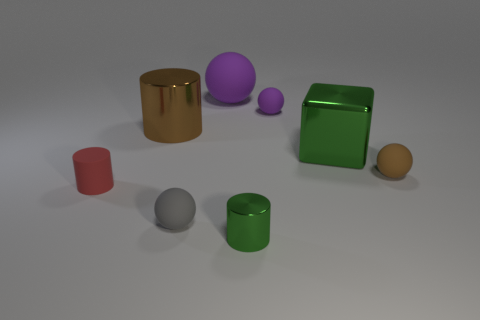How many other things are the same size as the red rubber thing? Based on visual estimation, there appear to be two objects that are roughly the same size as the red cylinder; these are the small green cylinder and the small orange sphere. 